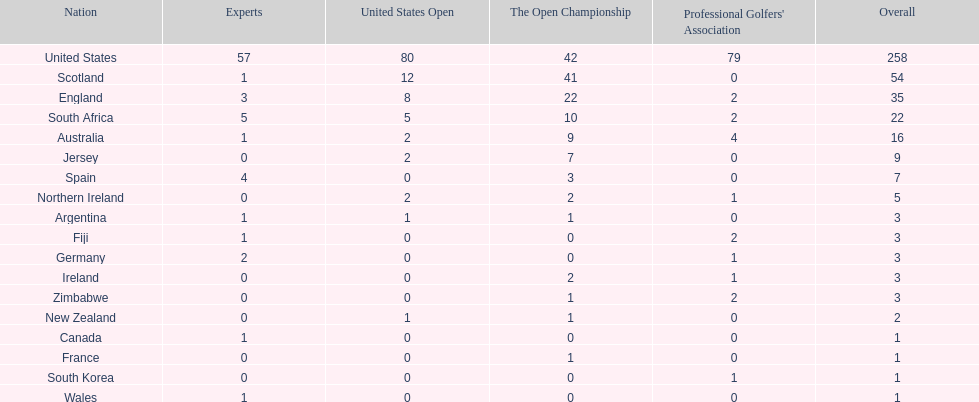How many u.s. open wins does fiji have? 0. 